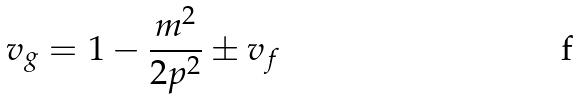<formula> <loc_0><loc_0><loc_500><loc_500>v _ { g } = 1 - \frac { m ^ { 2 } } { 2 p ^ { 2 } } \pm v _ { f }</formula> 